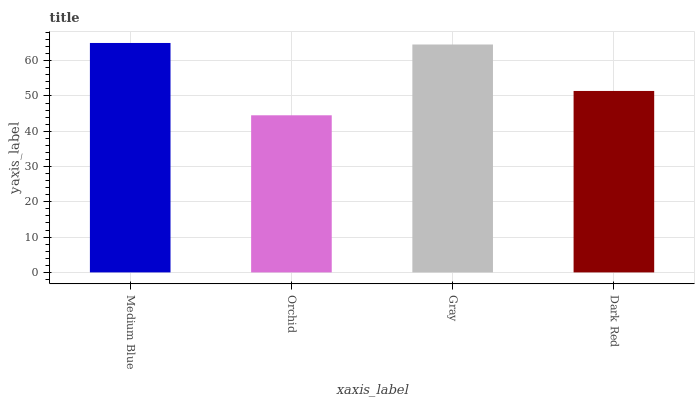Is Orchid the minimum?
Answer yes or no. Yes. Is Medium Blue the maximum?
Answer yes or no. Yes. Is Gray the minimum?
Answer yes or no. No. Is Gray the maximum?
Answer yes or no. No. Is Gray greater than Orchid?
Answer yes or no. Yes. Is Orchid less than Gray?
Answer yes or no. Yes. Is Orchid greater than Gray?
Answer yes or no. No. Is Gray less than Orchid?
Answer yes or no. No. Is Gray the high median?
Answer yes or no. Yes. Is Dark Red the low median?
Answer yes or no. Yes. Is Medium Blue the high median?
Answer yes or no. No. Is Medium Blue the low median?
Answer yes or no. No. 